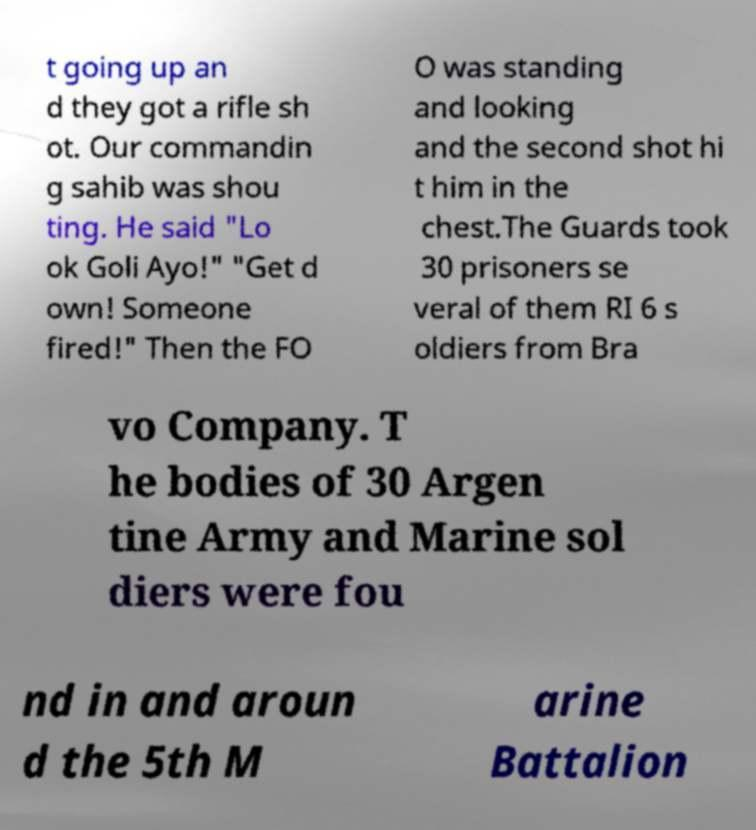There's text embedded in this image that I need extracted. Can you transcribe it verbatim? t going up an d they got a rifle sh ot. Our commandin g sahib was shou ting. He said "Lo ok Goli Ayo!" "Get d own! Someone fired!" Then the FO O was standing and looking and the second shot hi t him in the chest.The Guards took 30 prisoners se veral of them RI 6 s oldiers from Bra vo Company. T he bodies of 30 Argen tine Army and Marine sol diers were fou nd in and aroun d the 5th M arine Battalion 